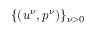Convert formula to latex. <formula><loc_0><loc_0><loc_500><loc_500>\{ ( u ^ { \nu } , p ^ { \nu } ) \} _ { \nu > 0 }</formula> 